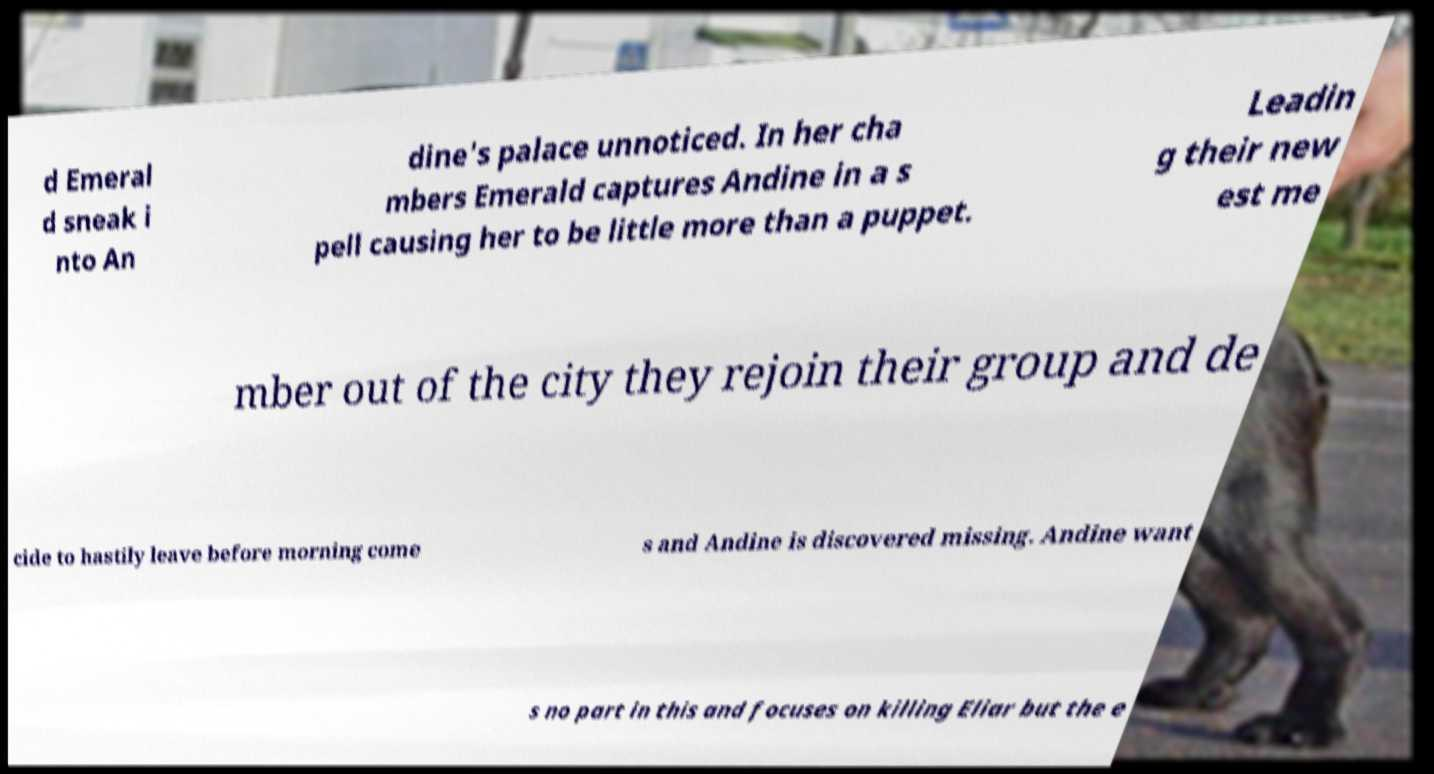Could you extract and type out the text from this image? d Emeral d sneak i nto An dine's palace unnoticed. In her cha mbers Emerald captures Andine in a s pell causing her to be little more than a puppet. Leadin g their new est me mber out of the city they rejoin their group and de cide to hastily leave before morning come s and Andine is discovered missing. Andine want s no part in this and focuses on killing Eliar but the e 